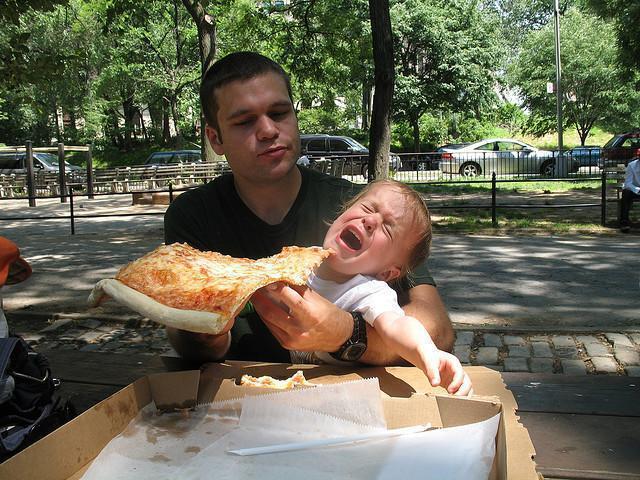What is the most popular pizza cheese?
Select the accurate response from the four choices given to answer the question.
Options: Cheddar, mozzarella, gouda, american. Mozzarella. 